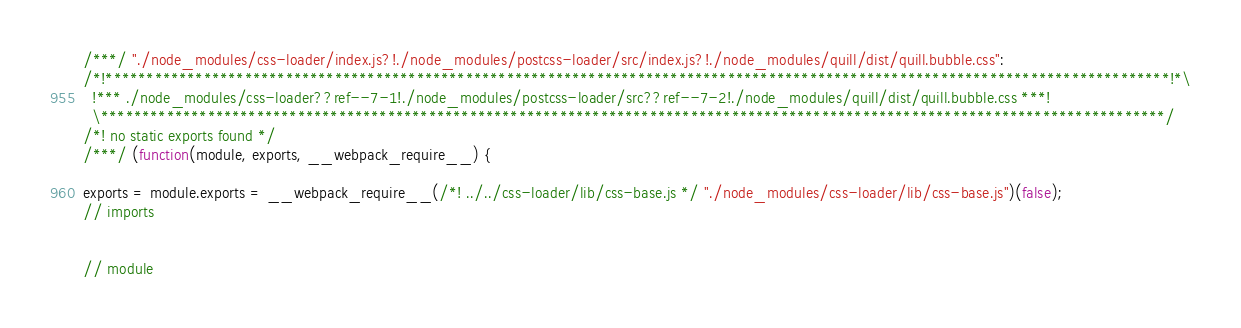Convert code to text. <code><loc_0><loc_0><loc_500><loc_500><_JavaScript_>
/***/ "./node_modules/css-loader/index.js?!./node_modules/postcss-loader/src/index.js?!./node_modules/quill/dist/quill.bubble.css":
/*!**********************************************************************************************************************************!*\
  !*** ./node_modules/css-loader??ref--7-1!./node_modules/postcss-loader/src??ref--7-2!./node_modules/quill/dist/quill.bubble.css ***!
  \**********************************************************************************************************************************/
/*! no static exports found */
/***/ (function(module, exports, __webpack_require__) {

exports = module.exports = __webpack_require__(/*! ../../css-loader/lib/css-base.js */ "./node_modules/css-loader/lib/css-base.js")(false);
// imports


// module</code> 